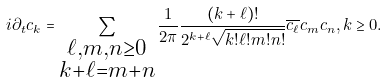<formula> <loc_0><loc_0><loc_500><loc_500>i \partial _ { t } c _ { k } = \sum _ { \substack { \ell , m , n \geq 0 \\ k + \ell = m + n } } \frac { 1 } { 2 \pi } \frac { ( k + \ell ) ! } { 2 ^ { k + \ell } \sqrt { k ! \ell ! m ! n ! } } \overline { c _ { \ell } } c _ { m } c _ { n } , k \geq 0 .</formula> 